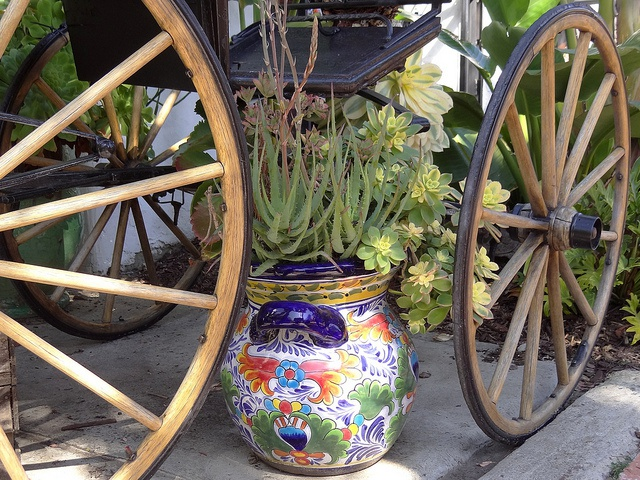Describe the objects in this image and their specific colors. I can see potted plant in lightyellow, gray, white, black, and olive tones and vase in lightyellow, white, gray, darkgray, and black tones in this image. 